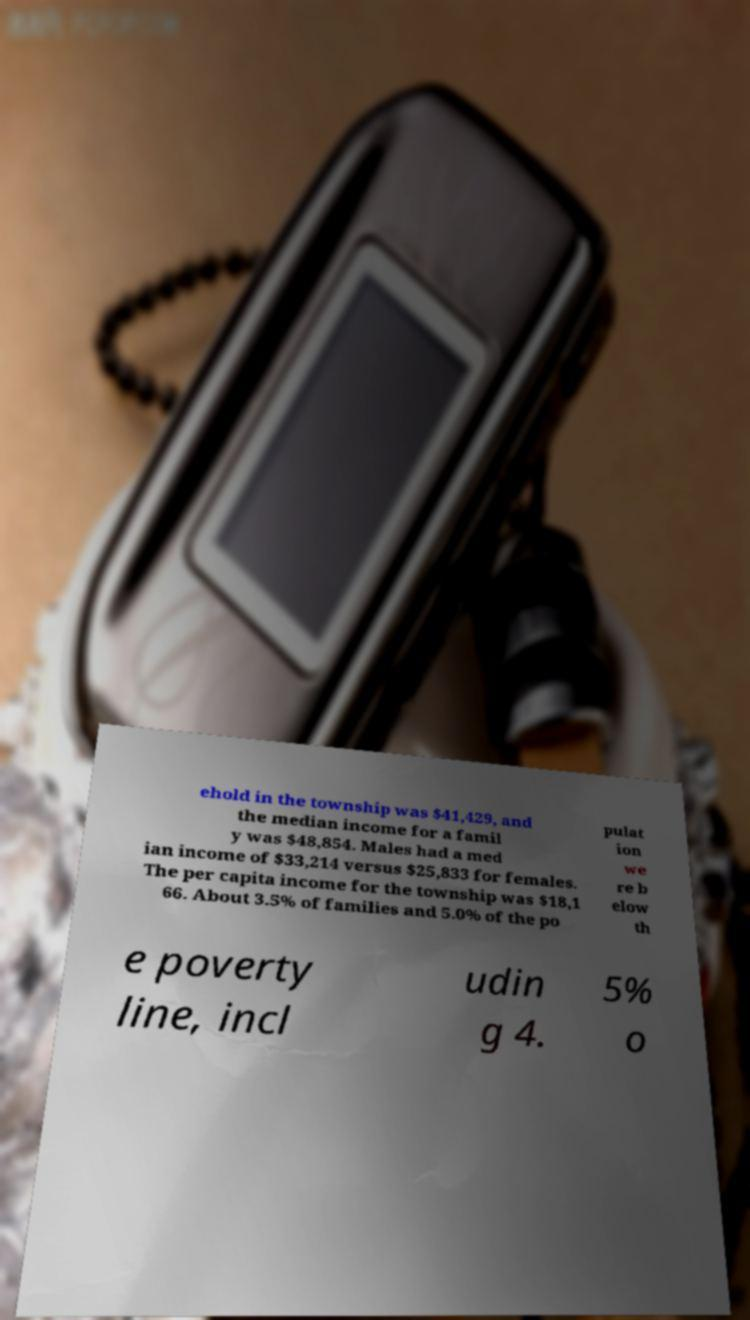Could you assist in decoding the text presented in this image and type it out clearly? ehold in the township was $41,429, and the median income for a famil y was $48,854. Males had a med ian income of $33,214 versus $25,833 for females. The per capita income for the township was $18,1 66. About 3.5% of families and 5.0% of the po pulat ion we re b elow th e poverty line, incl udin g 4. 5% o 